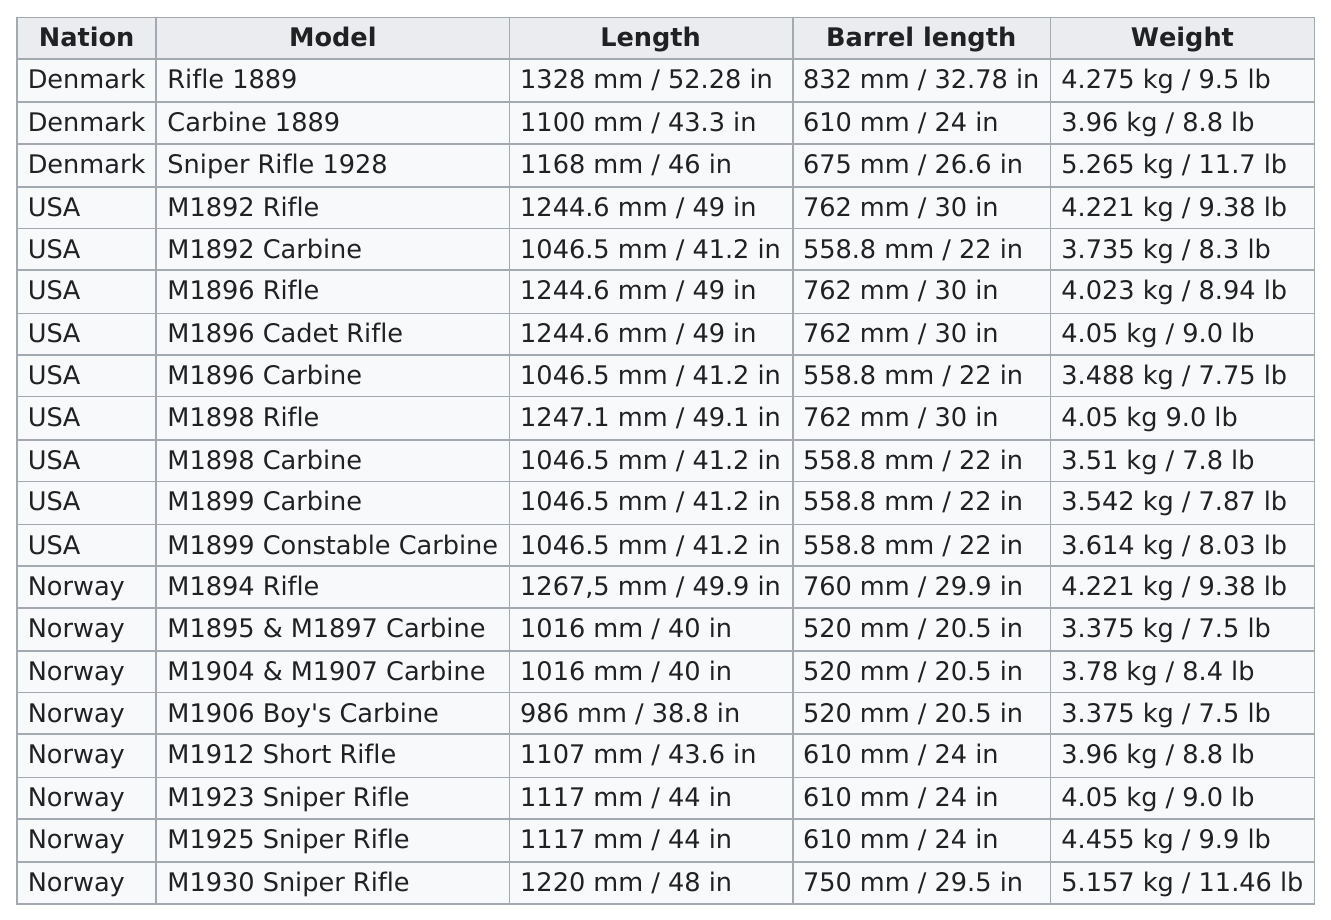Point out several critical features in this image. The rifle with the longest barrel is the 1889 Rifle. Four models are the same length as the m1898 carbine. Denmark has the least amount of service rifles listed among all nations. There are six rifles listed that have a weight higher than 9.0 lbs. There are at least 12 models that are at least 1100 mm in length. 